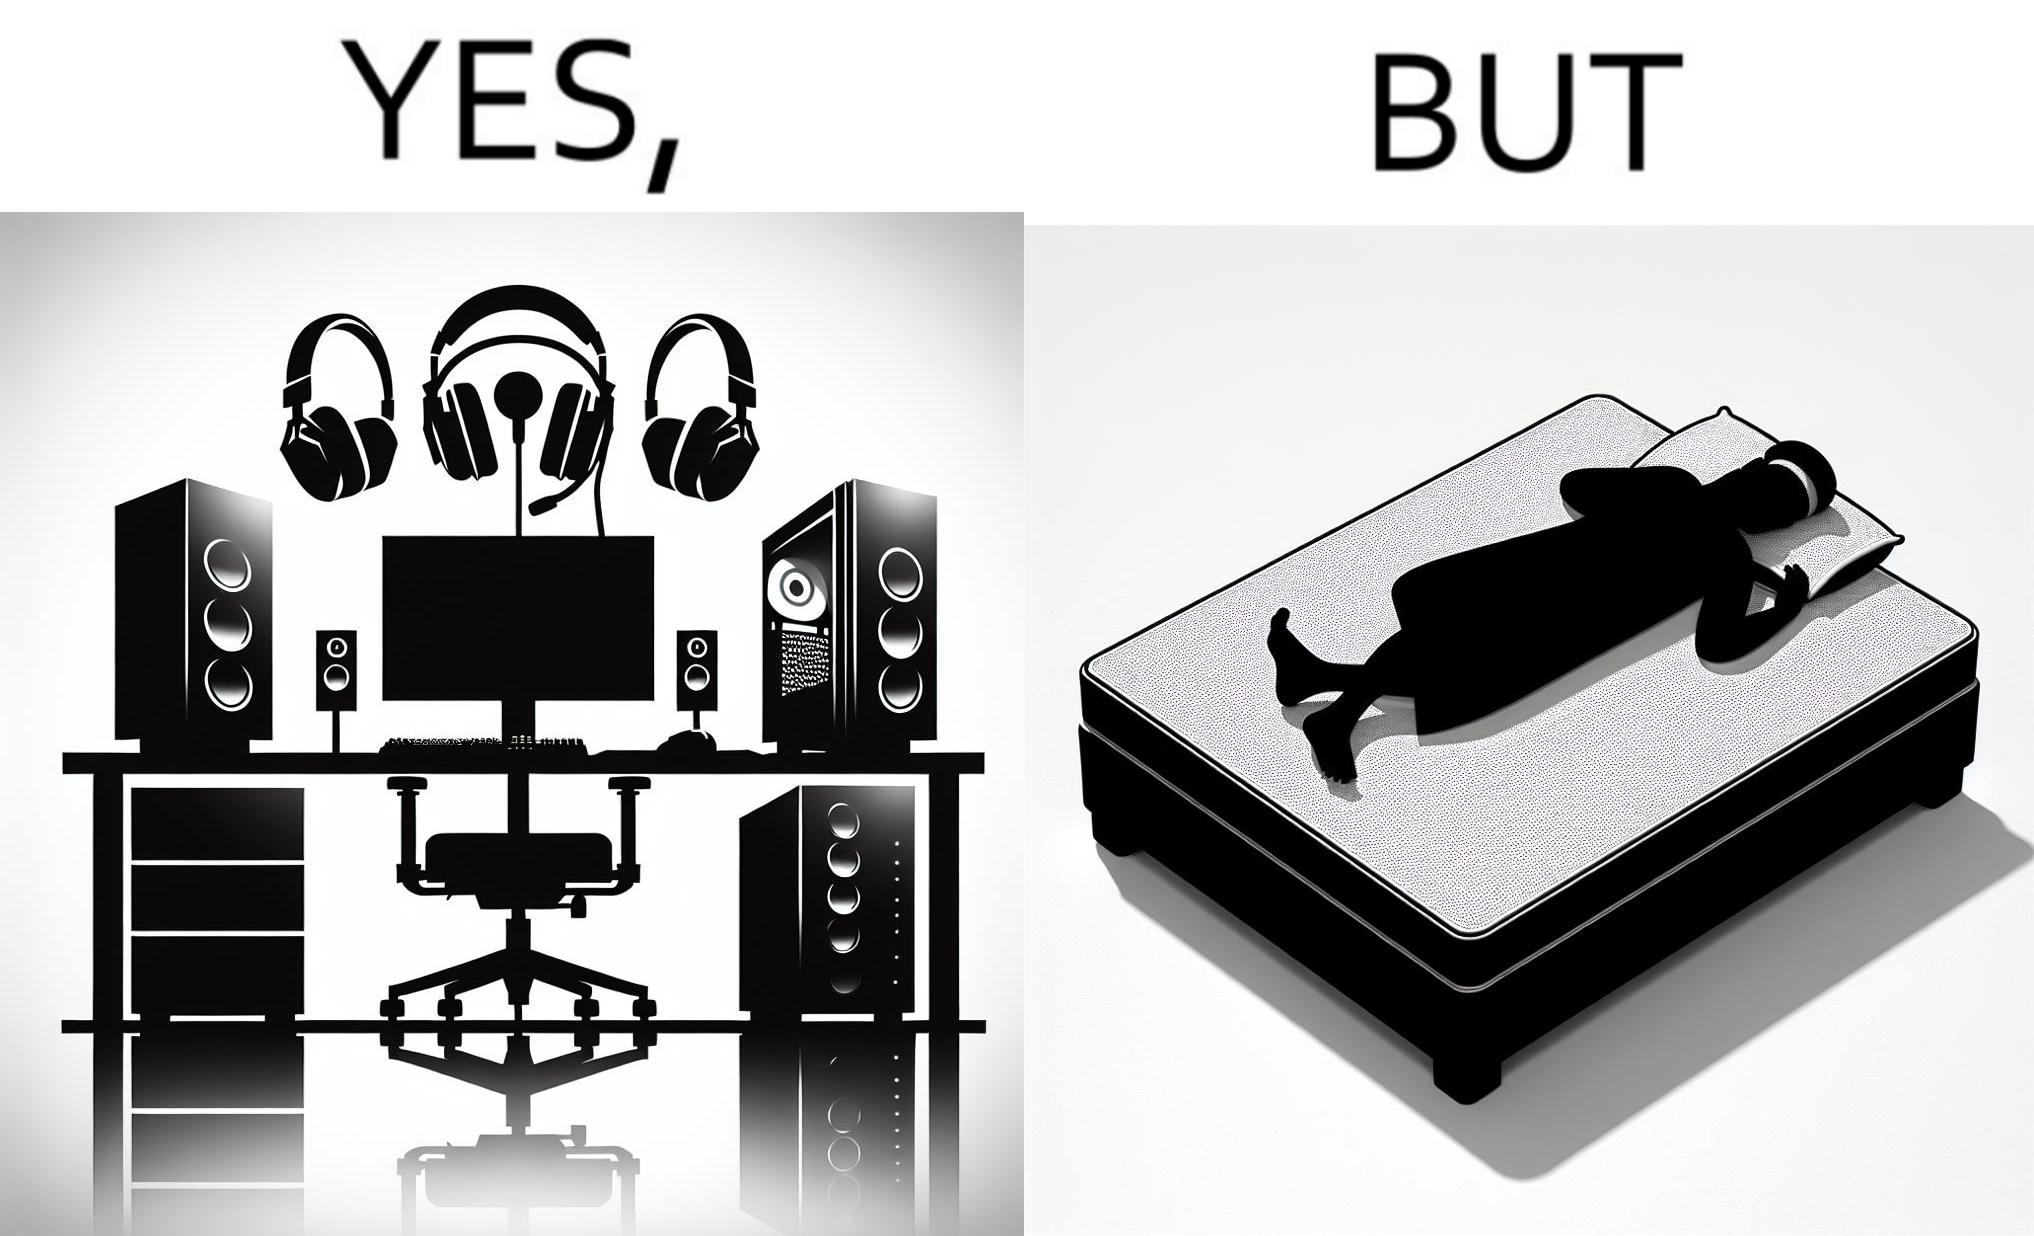Describe the satirical element in this image. The image is funny because the person has a lot of furniture for his computer but none for himself. 